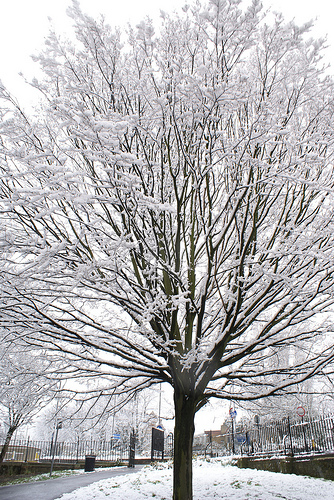<image>
Is the sky above the tree? Yes. The sky is positioned above the tree in the vertical space, higher up in the scene. 